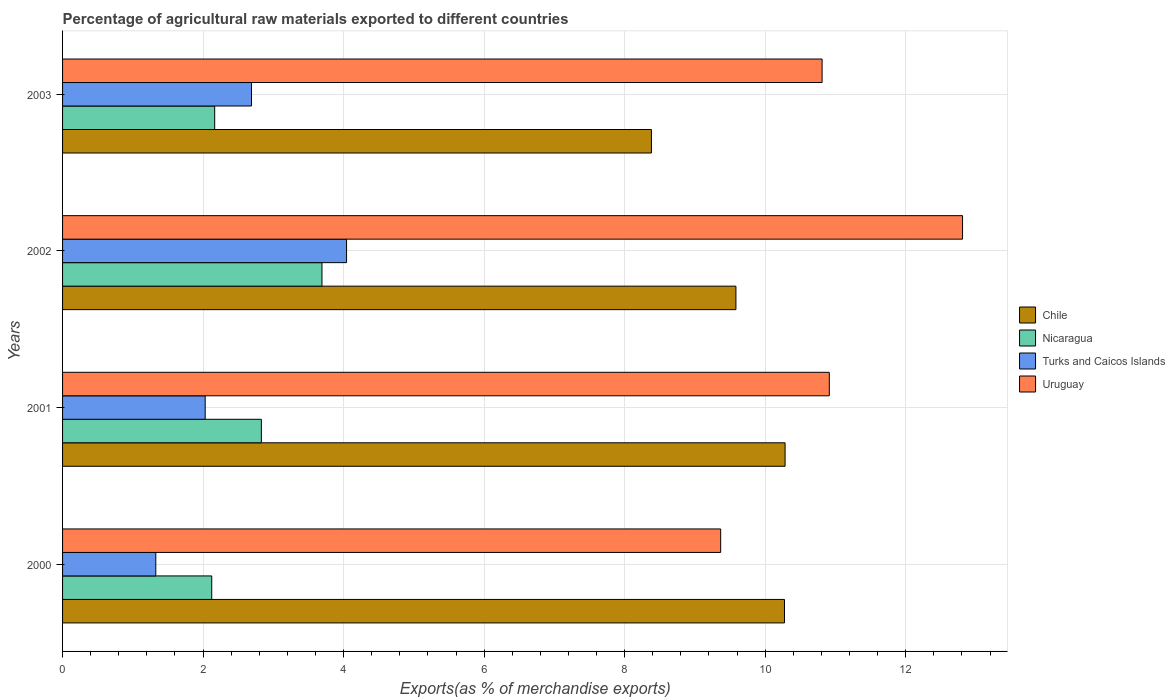How many different coloured bars are there?
Provide a short and direct response. 4. How many groups of bars are there?
Ensure brevity in your answer.  4. Are the number of bars per tick equal to the number of legend labels?
Make the answer very short. Yes. Are the number of bars on each tick of the Y-axis equal?
Give a very brief answer. Yes. How many bars are there on the 3rd tick from the top?
Make the answer very short. 4. What is the label of the 1st group of bars from the top?
Provide a succinct answer. 2003. In how many cases, is the number of bars for a given year not equal to the number of legend labels?
Make the answer very short. 0. What is the percentage of exports to different countries in Uruguay in 2003?
Ensure brevity in your answer.  10.81. Across all years, what is the maximum percentage of exports to different countries in Turks and Caicos Islands?
Your response must be concise. 4.04. Across all years, what is the minimum percentage of exports to different countries in Uruguay?
Your answer should be very brief. 9.37. What is the total percentage of exports to different countries in Chile in the graph?
Provide a short and direct response. 38.52. What is the difference between the percentage of exports to different countries in Chile in 2000 and that in 2003?
Give a very brief answer. 1.89. What is the difference between the percentage of exports to different countries in Nicaragua in 2000 and the percentage of exports to different countries in Chile in 2002?
Ensure brevity in your answer.  -7.46. What is the average percentage of exports to different countries in Uruguay per year?
Make the answer very short. 10.97. In the year 2003, what is the difference between the percentage of exports to different countries in Nicaragua and percentage of exports to different countries in Turks and Caicos Islands?
Offer a terse response. -0.52. What is the ratio of the percentage of exports to different countries in Turks and Caicos Islands in 2001 to that in 2002?
Provide a short and direct response. 0.5. Is the percentage of exports to different countries in Turks and Caicos Islands in 2002 less than that in 2003?
Your response must be concise. No. What is the difference between the highest and the second highest percentage of exports to different countries in Turks and Caicos Islands?
Your answer should be very brief. 1.35. What is the difference between the highest and the lowest percentage of exports to different countries in Uruguay?
Give a very brief answer. 3.44. In how many years, is the percentage of exports to different countries in Turks and Caicos Islands greater than the average percentage of exports to different countries in Turks and Caicos Islands taken over all years?
Your answer should be compact. 2. What does the 3rd bar from the bottom in 2003 represents?
Offer a terse response. Turks and Caicos Islands. Is it the case that in every year, the sum of the percentage of exports to different countries in Nicaragua and percentage of exports to different countries in Turks and Caicos Islands is greater than the percentage of exports to different countries in Chile?
Your answer should be very brief. No. What is the difference between two consecutive major ticks on the X-axis?
Your answer should be very brief. 2. Are the values on the major ticks of X-axis written in scientific E-notation?
Provide a succinct answer. No. Does the graph contain grids?
Offer a very short reply. Yes. How many legend labels are there?
Offer a terse response. 4. How are the legend labels stacked?
Provide a short and direct response. Vertical. What is the title of the graph?
Make the answer very short. Percentage of agricultural raw materials exported to different countries. Does "Cabo Verde" appear as one of the legend labels in the graph?
Your response must be concise. No. What is the label or title of the X-axis?
Your response must be concise. Exports(as % of merchandise exports). What is the label or title of the Y-axis?
Keep it short and to the point. Years. What is the Exports(as % of merchandise exports) of Chile in 2000?
Offer a very short reply. 10.27. What is the Exports(as % of merchandise exports) in Nicaragua in 2000?
Provide a succinct answer. 2.12. What is the Exports(as % of merchandise exports) of Turks and Caicos Islands in 2000?
Give a very brief answer. 1.33. What is the Exports(as % of merchandise exports) in Uruguay in 2000?
Make the answer very short. 9.37. What is the Exports(as % of merchandise exports) of Chile in 2001?
Make the answer very short. 10.28. What is the Exports(as % of merchandise exports) in Nicaragua in 2001?
Provide a succinct answer. 2.83. What is the Exports(as % of merchandise exports) of Turks and Caicos Islands in 2001?
Offer a terse response. 2.03. What is the Exports(as % of merchandise exports) of Uruguay in 2001?
Your response must be concise. 10.91. What is the Exports(as % of merchandise exports) of Chile in 2002?
Your answer should be very brief. 9.58. What is the Exports(as % of merchandise exports) of Nicaragua in 2002?
Offer a very short reply. 3.69. What is the Exports(as % of merchandise exports) of Turks and Caicos Islands in 2002?
Offer a terse response. 4.04. What is the Exports(as % of merchandise exports) in Uruguay in 2002?
Provide a succinct answer. 12.81. What is the Exports(as % of merchandise exports) in Chile in 2003?
Your answer should be very brief. 8.38. What is the Exports(as % of merchandise exports) of Nicaragua in 2003?
Offer a terse response. 2.17. What is the Exports(as % of merchandise exports) of Turks and Caicos Islands in 2003?
Your response must be concise. 2.69. What is the Exports(as % of merchandise exports) in Uruguay in 2003?
Make the answer very short. 10.81. Across all years, what is the maximum Exports(as % of merchandise exports) in Chile?
Provide a succinct answer. 10.28. Across all years, what is the maximum Exports(as % of merchandise exports) of Nicaragua?
Make the answer very short. 3.69. Across all years, what is the maximum Exports(as % of merchandise exports) in Turks and Caicos Islands?
Keep it short and to the point. 4.04. Across all years, what is the maximum Exports(as % of merchandise exports) in Uruguay?
Make the answer very short. 12.81. Across all years, what is the minimum Exports(as % of merchandise exports) in Chile?
Your answer should be very brief. 8.38. Across all years, what is the minimum Exports(as % of merchandise exports) of Nicaragua?
Offer a very short reply. 2.12. Across all years, what is the minimum Exports(as % of merchandise exports) in Turks and Caicos Islands?
Offer a very short reply. 1.33. Across all years, what is the minimum Exports(as % of merchandise exports) of Uruguay?
Keep it short and to the point. 9.37. What is the total Exports(as % of merchandise exports) in Chile in the graph?
Provide a succinct answer. 38.52. What is the total Exports(as % of merchandise exports) of Nicaragua in the graph?
Your response must be concise. 10.81. What is the total Exports(as % of merchandise exports) of Turks and Caicos Islands in the graph?
Ensure brevity in your answer.  10.09. What is the total Exports(as % of merchandise exports) in Uruguay in the graph?
Provide a short and direct response. 43.9. What is the difference between the Exports(as % of merchandise exports) of Chile in 2000 and that in 2001?
Your response must be concise. -0.01. What is the difference between the Exports(as % of merchandise exports) in Nicaragua in 2000 and that in 2001?
Offer a very short reply. -0.71. What is the difference between the Exports(as % of merchandise exports) in Turks and Caicos Islands in 2000 and that in 2001?
Give a very brief answer. -0.7. What is the difference between the Exports(as % of merchandise exports) of Uruguay in 2000 and that in 2001?
Your answer should be very brief. -1.55. What is the difference between the Exports(as % of merchandise exports) in Chile in 2000 and that in 2002?
Your answer should be compact. 0.69. What is the difference between the Exports(as % of merchandise exports) of Nicaragua in 2000 and that in 2002?
Make the answer very short. -1.57. What is the difference between the Exports(as % of merchandise exports) of Turks and Caicos Islands in 2000 and that in 2002?
Give a very brief answer. -2.72. What is the difference between the Exports(as % of merchandise exports) in Uruguay in 2000 and that in 2002?
Your answer should be very brief. -3.44. What is the difference between the Exports(as % of merchandise exports) in Chile in 2000 and that in 2003?
Provide a short and direct response. 1.89. What is the difference between the Exports(as % of merchandise exports) in Nicaragua in 2000 and that in 2003?
Ensure brevity in your answer.  -0.04. What is the difference between the Exports(as % of merchandise exports) of Turks and Caicos Islands in 2000 and that in 2003?
Your answer should be very brief. -1.36. What is the difference between the Exports(as % of merchandise exports) in Uruguay in 2000 and that in 2003?
Give a very brief answer. -1.44. What is the difference between the Exports(as % of merchandise exports) in Chile in 2001 and that in 2002?
Ensure brevity in your answer.  0.7. What is the difference between the Exports(as % of merchandise exports) in Nicaragua in 2001 and that in 2002?
Your answer should be very brief. -0.86. What is the difference between the Exports(as % of merchandise exports) of Turks and Caicos Islands in 2001 and that in 2002?
Offer a very short reply. -2.01. What is the difference between the Exports(as % of merchandise exports) of Uruguay in 2001 and that in 2002?
Your answer should be very brief. -1.9. What is the difference between the Exports(as % of merchandise exports) of Chile in 2001 and that in 2003?
Offer a very short reply. 1.9. What is the difference between the Exports(as % of merchandise exports) of Nicaragua in 2001 and that in 2003?
Offer a terse response. 0.66. What is the difference between the Exports(as % of merchandise exports) of Turks and Caicos Islands in 2001 and that in 2003?
Provide a short and direct response. -0.66. What is the difference between the Exports(as % of merchandise exports) in Uruguay in 2001 and that in 2003?
Give a very brief answer. 0.1. What is the difference between the Exports(as % of merchandise exports) of Chile in 2002 and that in 2003?
Ensure brevity in your answer.  1.2. What is the difference between the Exports(as % of merchandise exports) in Nicaragua in 2002 and that in 2003?
Your response must be concise. 1.53. What is the difference between the Exports(as % of merchandise exports) in Turks and Caicos Islands in 2002 and that in 2003?
Offer a very short reply. 1.35. What is the difference between the Exports(as % of merchandise exports) in Uruguay in 2002 and that in 2003?
Provide a short and direct response. 2. What is the difference between the Exports(as % of merchandise exports) in Chile in 2000 and the Exports(as % of merchandise exports) in Nicaragua in 2001?
Your answer should be very brief. 7.45. What is the difference between the Exports(as % of merchandise exports) in Chile in 2000 and the Exports(as % of merchandise exports) in Turks and Caicos Islands in 2001?
Provide a succinct answer. 8.24. What is the difference between the Exports(as % of merchandise exports) of Chile in 2000 and the Exports(as % of merchandise exports) of Uruguay in 2001?
Ensure brevity in your answer.  -0.64. What is the difference between the Exports(as % of merchandise exports) in Nicaragua in 2000 and the Exports(as % of merchandise exports) in Turks and Caicos Islands in 2001?
Provide a succinct answer. 0.09. What is the difference between the Exports(as % of merchandise exports) of Nicaragua in 2000 and the Exports(as % of merchandise exports) of Uruguay in 2001?
Your answer should be very brief. -8.79. What is the difference between the Exports(as % of merchandise exports) of Turks and Caicos Islands in 2000 and the Exports(as % of merchandise exports) of Uruguay in 2001?
Give a very brief answer. -9.59. What is the difference between the Exports(as % of merchandise exports) in Chile in 2000 and the Exports(as % of merchandise exports) in Nicaragua in 2002?
Your response must be concise. 6.58. What is the difference between the Exports(as % of merchandise exports) of Chile in 2000 and the Exports(as % of merchandise exports) of Turks and Caicos Islands in 2002?
Keep it short and to the point. 6.23. What is the difference between the Exports(as % of merchandise exports) in Chile in 2000 and the Exports(as % of merchandise exports) in Uruguay in 2002?
Your answer should be very brief. -2.53. What is the difference between the Exports(as % of merchandise exports) of Nicaragua in 2000 and the Exports(as % of merchandise exports) of Turks and Caicos Islands in 2002?
Provide a succinct answer. -1.92. What is the difference between the Exports(as % of merchandise exports) in Nicaragua in 2000 and the Exports(as % of merchandise exports) in Uruguay in 2002?
Ensure brevity in your answer.  -10.69. What is the difference between the Exports(as % of merchandise exports) of Turks and Caicos Islands in 2000 and the Exports(as % of merchandise exports) of Uruguay in 2002?
Make the answer very short. -11.48. What is the difference between the Exports(as % of merchandise exports) of Chile in 2000 and the Exports(as % of merchandise exports) of Nicaragua in 2003?
Offer a terse response. 8.11. What is the difference between the Exports(as % of merchandise exports) in Chile in 2000 and the Exports(as % of merchandise exports) in Turks and Caicos Islands in 2003?
Your answer should be compact. 7.59. What is the difference between the Exports(as % of merchandise exports) in Chile in 2000 and the Exports(as % of merchandise exports) in Uruguay in 2003?
Give a very brief answer. -0.54. What is the difference between the Exports(as % of merchandise exports) in Nicaragua in 2000 and the Exports(as % of merchandise exports) in Turks and Caicos Islands in 2003?
Ensure brevity in your answer.  -0.57. What is the difference between the Exports(as % of merchandise exports) of Nicaragua in 2000 and the Exports(as % of merchandise exports) of Uruguay in 2003?
Offer a terse response. -8.69. What is the difference between the Exports(as % of merchandise exports) in Turks and Caicos Islands in 2000 and the Exports(as % of merchandise exports) in Uruguay in 2003?
Ensure brevity in your answer.  -9.48. What is the difference between the Exports(as % of merchandise exports) in Chile in 2001 and the Exports(as % of merchandise exports) in Nicaragua in 2002?
Keep it short and to the point. 6.59. What is the difference between the Exports(as % of merchandise exports) of Chile in 2001 and the Exports(as % of merchandise exports) of Turks and Caicos Islands in 2002?
Make the answer very short. 6.24. What is the difference between the Exports(as % of merchandise exports) of Chile in 2001 and the Exports(as % of merchandise exports) of Uruguay in 2002?
Give a very brief answer. -2.53. What is the difference between the Exports(as % of merchandise exports) in Nicaragua in 2001 and the Exports(as % of merchandise exports) in Turks and Caicos Islands in 2002?
Provide a short and direct response. -1.21. What is the difference between the Exports(as % of merchandise exports) in Nicaragua in 2001 and the Exports(as % of merchandise exports) in Uruguay in 2002?
Your answer should be very brief. -9.98. What is the difference between the Exports(as % of merchandise exports) of Turks and Caicos Islands in 2001 and the Exports(as % of merchandise exports) of Uruguay in 2002?
Ensure brevity in your answer.  -10.78. What is the difference between the Exports(as % of merchandise exports) in Chile in 2001 and the Exports(as % of merchandise exports) in Nicaragua in 2003?
Your answer should be compact. 8.12. What is the difference between the Exports(as % of merchandise exports) of Chile in 2001 and the Exports(as % of merchandise exports) of Turks and Caicos Islands in 2003?
Your response must be concise. 7.59. What is the difference between the Exports(as % of merchandise exports) of Chile in 2001 and the Exports(as % of merchandise exports) of Uruguay in 2003?
Your answer should be very brief. -0.53. What is the difference between the Exports(as % of merchandise exports) in Nicaragua in 2001 and the Exports(as % of merchandise exports) in Turks and Caicos Islands in 2003?
Provide a succinct answer. 0.14. What is the difference between the Exports(as % of merchandise exports) in Nicaragua in 2001 and the Exports(as % of merchandise exports) in Uruguay in 2003?
Provide a succinct answer. -7.98. What is the difference between the Exports(as % of merchandise exports) of Turks and Caicos Islands in 2001 and the Exports(as % of merchandise exports) of Uruguay in 2003?
Offer a terse response. -8.78. What is the difference between the Exports(as % of merchandise exports) of Chile in 2002 and the Exports(as % of merchandise exports) of Nicaragua in 2003?
Provide a succinct answer. 7.42. What is the difference between the Exports(as % of merchandise exports) in Chile in 2002 and the Exports(as % of merchandise exports) in Turks and Caicos Islands in 2003?
Keep it short and to the point. 6.89. What is the difference between the Exports(as % of merchandise exports) in Chile in 2002 and the Exports(as % of merchandise exports) in Uruguay in 2003?
Offer a terse response. -1.23. What is the difference between the Exports(as % of merchandise exports) of Nicaragua in 2002 and the Exports(as % of merchandise exports) of Uruguay in 2003?
Your answer should be very brief. -7.12. What is the difference between the Exports(as % of merchandise exports) of Turks and Caicos Islands in 2002 and the Exports(as % of merchandise exports) of Uruguay in 2003?
Give a very brief answer. -6.77. What is the average Exports(as % of merchandise exports) of Chile per year?
Make the answer very short. 9.63. What is the average Exports(as % of merchandise exports) of Nicaragua per year?
Your answer should be compact. 2.7. What is the average Exports(as % of merchandise exports) of Turks and Caicos Islands per year?
Offer a terse response. 2.52. What is the average Exports(as % of merchandise exports) in Uruguay per year?
Make the answer very short. 10.97. In the year 2000, what is the difference between the Exports(as % of merchandise exports) of Chile and Exports(as % of merchandise exports) of Nicaragua?
Your answer should be compact. 8.15. In the year 2000, what is the difference between the Exports(as % of merchandise exports) of Chile and Exports(as % of merchandise exports) of Turks and Caicos Islands?
Keep it short and to the point. 8.95. In the year 2000, what is the difference between the Exports(as % of merchandise exports) of Chile and Exports(as % of merchandise exports) of Uruguay?
Ensure brevity in your answer.  0.91. In the year 2000, what is the difference between the Exports(as % of merchandise exports) in Nicaragua and Exports(as % of merchandise exports) in Turks and Caicos Islands?
Ensure brevity in your answer.  0.8. In the year 2000, what is the difference between the Exports(as % of merchandise exports) of Nicaragua and Exports(as % of merchandise exports) of Uruguay?
Provide a short and direct response. -7.24. In the year 2000, what is the difference between the Exports(as % of merchandise exports) in Turks and Caicos Islands and Exports(as % of merchandise exports) in Uruguay?
Provide a short and direct response. -8.04. In the year 2001, what is the difference between the Exports(as % of merchandise exports) in Chile and Exports(as % of merchandise exports) in Nicaragua?
Ensure brevity in your answer.  7.45. In the year 2001, what is the difference between the Exports(as % of merchandise exports) in Chile and Exports(as % of merchandise exports) in Turks and Caicos Islands?
Your response must be concise. 8.25. In the year 2001, what is the difference between the Exports(as % of merchandise exports) in Chile and Exports(as % of merchandise exports) in Uruguay?
Ensure brevity in your answer.  -0.63. In the year 2001, what is the difference between the Exports(as % of merchandise exports) in Nicaragua and Exports(as % of merchandise exports) in Turks and Caicos Islands?
Ensure brevity in your answer.  0.8. In the year 2001, what is the difference between the Exports(as % of merchandise exports) in Nicaragua and Exports(as % of merchandise exports) in Uruguay?
Offer a terse response. -8.08. In the year 2001, what is the difference between the Exports(as % of merchandise exports) in Turks and Caicos Islands and Exports(as % of merchandise exports) in Uruguay?
Make the answer very short. -8.88. In the year 2002, what is the difference between the Exports(as % of merchandise exports) in Chile and Exports(as % of merchandise exports) in Nicaragua?
Offer a terse response. 5.89. In the year 2002, what is the difference between the Exports(as % of merchandise exports) in Chile and Exports(as % of merchandise exports) in Turks and Caicos Islands?
Keep it short and to the point. 5.54. In the year 2002, what is the difference between the Exports(as % of merchandise exports) of Chile and Exports(as % of merchandise exports) of Uruguay?
Provide a short and direct response. -3.23. In the year 2002, what is the difference between the Exports(as % of merchandise exports) of Nicaragua and Exports(as % of merchandise exports) of Turks and Caicos Islands?
Give a very brief answer. -0.35. In the year 2002, what is the difference between the Exports(as % of merchandise exports) in Nicaragua and Exports(as % of merchandise exports) in Uruguay?
Your answer should be very brief. -9.12. In the year 2002, what is the difference between the Exports(as % of merchandise exports) of Turks and Caicos Islands and Exports(as % of merchandise exports) of Uruguay?
Offer a very short reply. -8.77. In the year 2003, what is the difference between the Exports(as % of merchandise exports) in Chile and Exports(as % of merchandise exports) in Nicaragua?
Your response must be concise. 6.22. In the year 2003, what is the difference between the Exports(as % of merchandise exports) of Chile and Exports(as % of merchandise exports) of Turks and Caicos Islands?
Make the answer very short. 5.69. In the year 2003, what is the difference between the Exports(as % of merchandise exports) of Chile and Exports(as % of merchandise exports) of Uruguay?
Ensure brevity in your answer.  -2.43. In the year 2003, what is the difference between the Exports(as % of merchandise exports) in Nicaragua and Exports(as % of merchandise exports) in Turks and Caicos Islands?
Offer a very short reply. -0.52. In the year 2003, what is the difference between the Exports(as % of merchandise exports) in Nicaragua and Exports(as % of merchandise exports) in Uruguay?
Provide a short and direct response. -8.65. In the year 2003, what is the difference between the Exports(as % of merchandise exports) in Turks and Caicos Islands and Exports(as % of merchandise exports) in Uruguay?
Give a very brief answer. -8.12. What is the ratio of the Exports(as % of merchandise exports) of Chile in 2000 to that in 2001?
Your answer should be very brief. 1. What is the ratio of the Exports(as % of merchandise exports) in Nicaragua in 2000 to that in 2001?
Provide a short and direct response. 0.75. What is the ratio of the Exports(as % of merchandise exports) of Turks and Caicos Islands in 2000 to that in 2001?
Your answer should be compact. 0.65. What is the ratio of the Exports(as % of merchandise exports) in Uruguay in 2000 to that in 2001?
Your response must be concise. 0.86. What is the ratio of the Exports(as % of merchandise exports) in Chile in 2000 to that in 2002?
Provide a short and direct response. 1.07. What is the ratio of the Exports(as % of merchandise exports) in Nicaragua in 2000 to that in 2002?
Keep it short and to the point. 0.58. What is the ratio of the Exports(as % of merchandise exports) in Turks and Caicos Islands in 2000 to that in 2002?
Offer a terse response. 0.33. What is the ratio of the Exports(as % of merchandise exports) of Uruguay in 2000 to that in 2002?
Offer a very short reply. 0.73. What is the ratio of the Exports(as % of merchandise exports) of Chile in 2000 to that in 2003?
Make the answer very short. 1.23. What is the ratio of the Exports(as % of merchandise exports) in Nicaragua in 2000 to that in 2003?
Give a very brief answer. 0.98. What is the ratio of the Exports(as % of merchandise exports) of Turks and Caicos Islands in 2000 to that in 2003?
Your response must be concise. 0.49. What is the ratio of the Exports(as % of merchandise exports) in Uruguay in 2000 to that in 2003?
Make the answer very short. 0.87. What is the ratio of the Exports(as % of merchandise exports) in Chile in 2001 to that in 2002?
Keep it short and to the point. 1.07. What is the ratio of the Exports(as % of merchandise exports) of Nicaragua in 2001 to that in 2002?
Your answer should be very brief. 0.77. What is the ratio of the Exports(as % of merchandise exports) in Turks and Caicos Islands in 2001 to that in 2002?
Provide a succinct answer. 0.5. What is the ratio of the Exports(as % of merchandise exports) of Uruguay in 2001 to that in 2002?
Offer a terse response. 0.85. What is the ratio of the Exports(as % of merchandise exports) of Chile in 2001 to that in 2003?
Your response must be concise. 1.23. What is the ratio of the Exports(as % of merchandise exports) of Nicaragua in 2001 to that in 2003?
Your answer should be compact. 1.31. What is the ratio of the Exports(as % of merchandise exports) in Turks and Caicos Islands in 2001 to that in 2003?
Provide a succinct answer. 0.76. What is the ratio of the Exports(as % of merchandise exports) in Uruguay in 2001 to that in 2003?
Give a very brief answer. 1.01. What is the ratio of the Exports(as % of merchandise exports) of Chile in 2002 to that in 2003?
Offer a terse response. 1.14. What is the ratio of the Exports(as % of merchandise exports) of Nicaragua in 2002 to that in 2003?
Provide a short and direct response. 1.71. What is the ratio of the Exports(as % of merchandise exports) of Turks and Caicos Islands in 2002 to that in 2003?
Your response must be concise. 1.5. What is the ratio of the Exports(as % of merchandise exports) of Uruguay in 2002 to that in 2003?
Provide a succinct answer. 1.18. What is the difference between the highest and the second highest Exports(as % of merchandise exports) in Chile?
Offer a very short reply. 0.01. What is the difference between the highest and the second highest Exports(as % of merchandise exports) in Nicaragua?
Your answer should be very brief. 0.86. What is the difference between the highest and the second highest Exports(as % of merchandise exports) of Turks and Caicos Islands?
Ensure brevity in your answer.  1.35. What is the difference between the highest and the second highest Exports(as % of merchandise exports) of Uruguay?
Provide a short and direct response. 1.9. What is the difference between the highest and the lowest Exports(as % of merchandise exports) in Chile?
Give a very brief answer. 1.9. What is the difference between the highest and the lowest Exports(as % of merchandise exports) of Nicaragua?
Provide a succinct answer. 1.57. What is the difference between the highest and the lowest Exports(as % of merchandise exports) in Turks and Caicos Islands?
Your answer should be compact. 2.72. What is the difference between the highest and the lowest Exports(as % of merchandise exports) in Uruguay?
Your answer should be very brief. 3.44. 